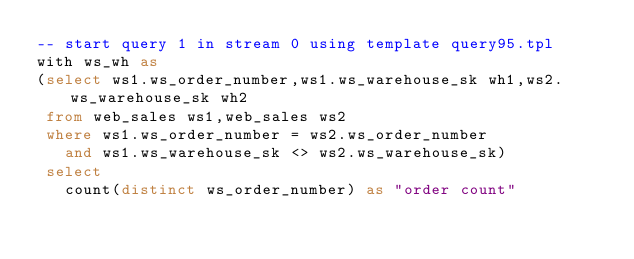<code> <loc_0><loc_0><loc_500><loc_500><_SQL_>-- start query 1 in stream 0 using template query95.tpl
with ws_wh as
(select ws1.ws_order_number,ws1.ws_warehouse_sk wh1,ws2.ws_warehouse_sk wh2
 from web_sales ws1,web_sales ws2
 where ws1.ws_order_number = ws2.ws_order_number
   and ws1.ws_warehouse_sk <> ws2.ws_warehouse_sk)
 select  
   count(distinct ws_order_number) as "order count"</code> 